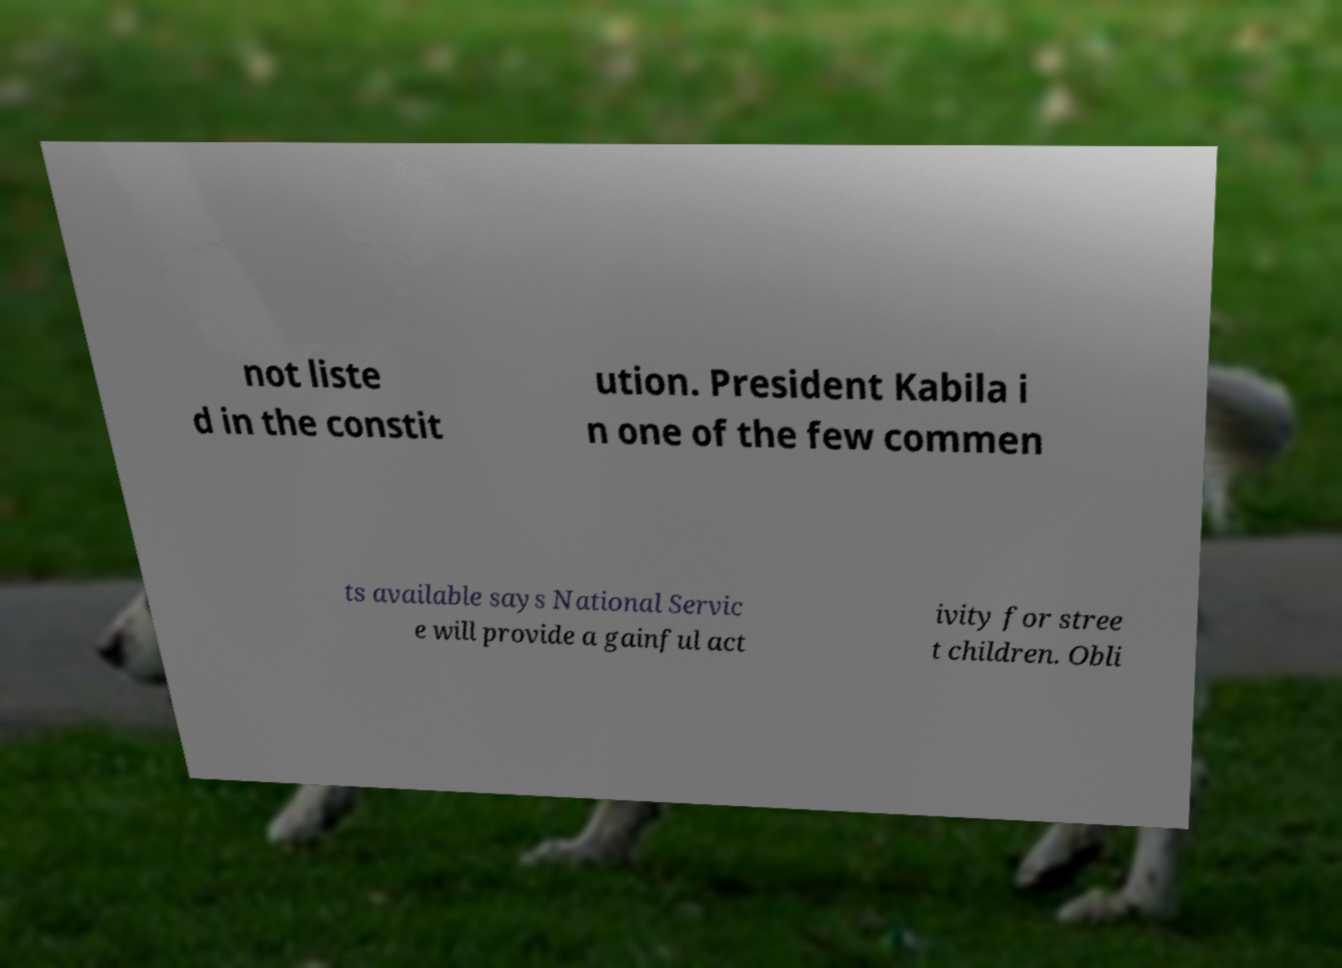Can you read and provide the text displayed in the image?This photo seems to have some interesting text. Can you extract and type it out for me? not liste d in the constit ution. President Kabila i n one of the few commen ts available says National Servic e will provide a gainful act ivity for stree t children. Obli 